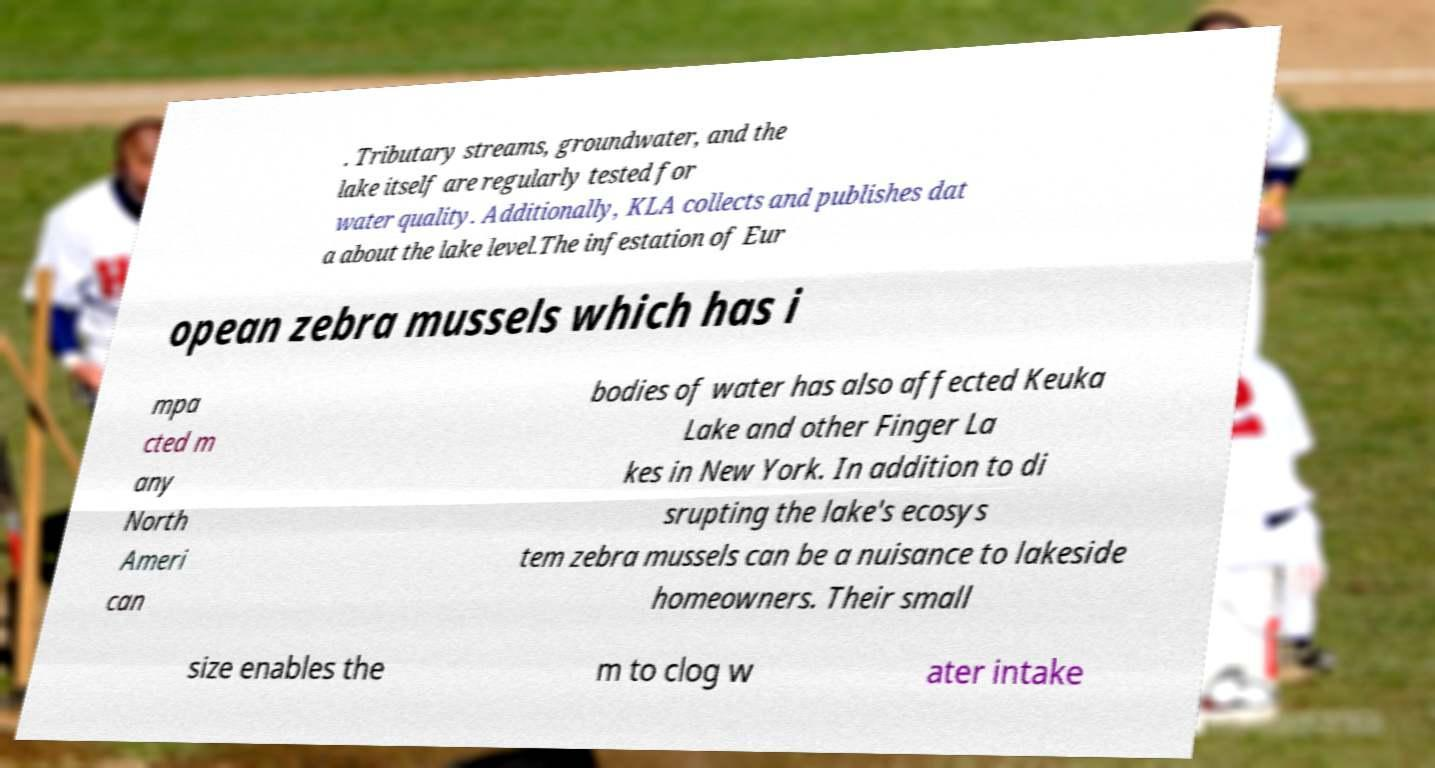Please read and relay the text visible in this image. What does it say? . Tributary streams, groundwater, and the lake itself are regularly tested for water quality. Additionally, KLA collects and publishes dat a about the lake level.The infestation of Eur opean zebra mussels which has i mpa cted m any North Ameri can bodies of water has also affected Keuka Lake and other Finger La kes in New York. In addition to di srupting the lake's ecosys tem zebra mussels can be a nuisance to lakeside homeowners. Their small size enables the m to clog w ater intake 